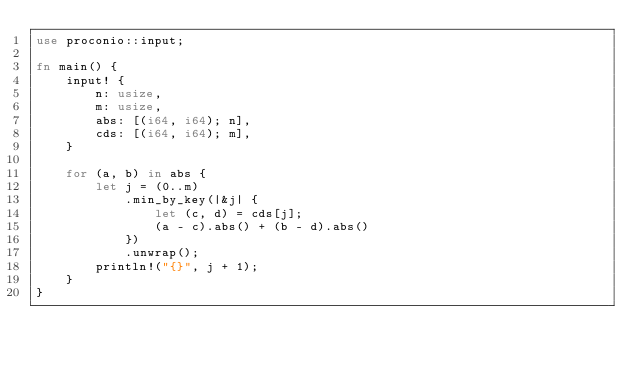<code> <loc_0><loc_0><loc_500><loc_500><_Rust_>use proconio::input;

fn main() {
    input! {
        n: usize,
        m: usize,
        abs: [(i64, i64); n],
        cds: [(i64, i64); m],
    }

    for (a, b) in abs {
        let j = (0..m)
            .min_by_key(|&j| {
                let (c, d) = cds[j];
                (a - c).abs() + (b - d).abs()
            })
            .unwrap();
        println!("{}", j + 1);
    }
}</code> 